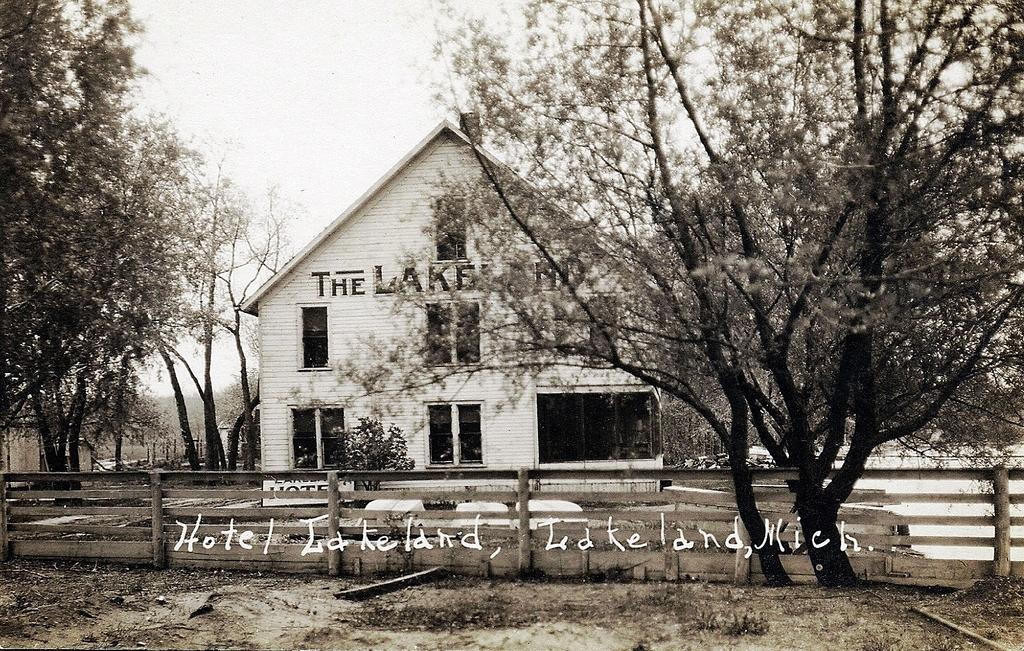Provide a one-sentence caption for the provided image. A sepia filer photo of a home by trees with the words Hotel Lakeland, Lakeland Mich. written over the photo. 